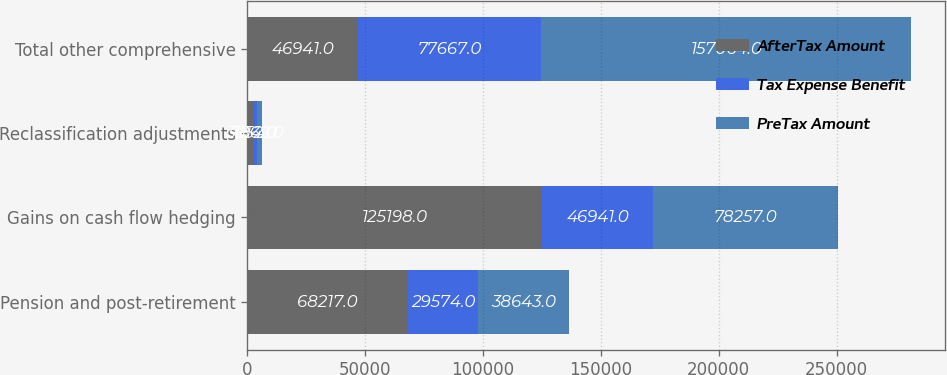<chart> <loc_0><loc_0><loc_500><loc_500><stacked_bar_chart><ecel><fcel>Pension and post-retirement<fcel>Gains on cash flow hedging<fcel>Reclassification adjustments<fcel>Total other comprehensive<nl><fcel>AfterTax Amount<fcel>68217<fcel>125198<fcel>3014<fcel>46941<nl><fcel>Tax Expense Benefit<fcel>29574<fcel>46941<fcel>1152<fcel>77667<nl><fcel>PreTax Amount<fcel>38643<fcel>78257<fcel>1862<fcel>157064<nl></chart> 